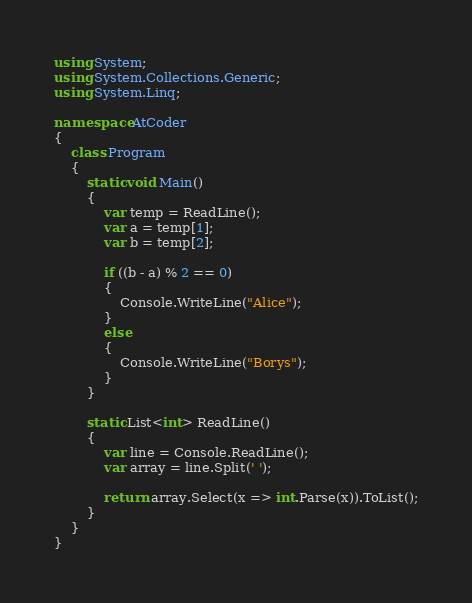Convert code to text. <code><loc_0><loc_0><loc_500><loc_500><_C#_>using System;
using System.Collections.Generic;
using System.Linq;

namespace AtCoder
{
    class Program
    {
        static void Main()
        {
            var temp = ReadLine();
            var a = temp[1];
            var b = temp[2];

            if ((b - a) % 2 == 0)
            {
                Console.WriteLine("Alice");
            }
            else
            {
                Console.WriteLine("Borys");
            }
        }

        static List<int> ReadLine()
        {
            var line = Console.ReadLine();
            var array = line.Split(' ');

            return array.Select(x => int.Parse(x)).ToList();
        }
    }
}</code> 